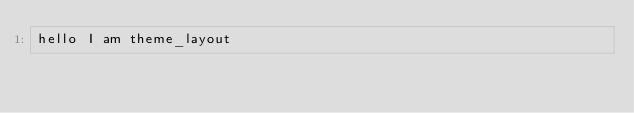Convert code to text. <code><loc_0><loc_0><loc_500><loc_500><_HTML_>hello I am theme_layout
</code> 